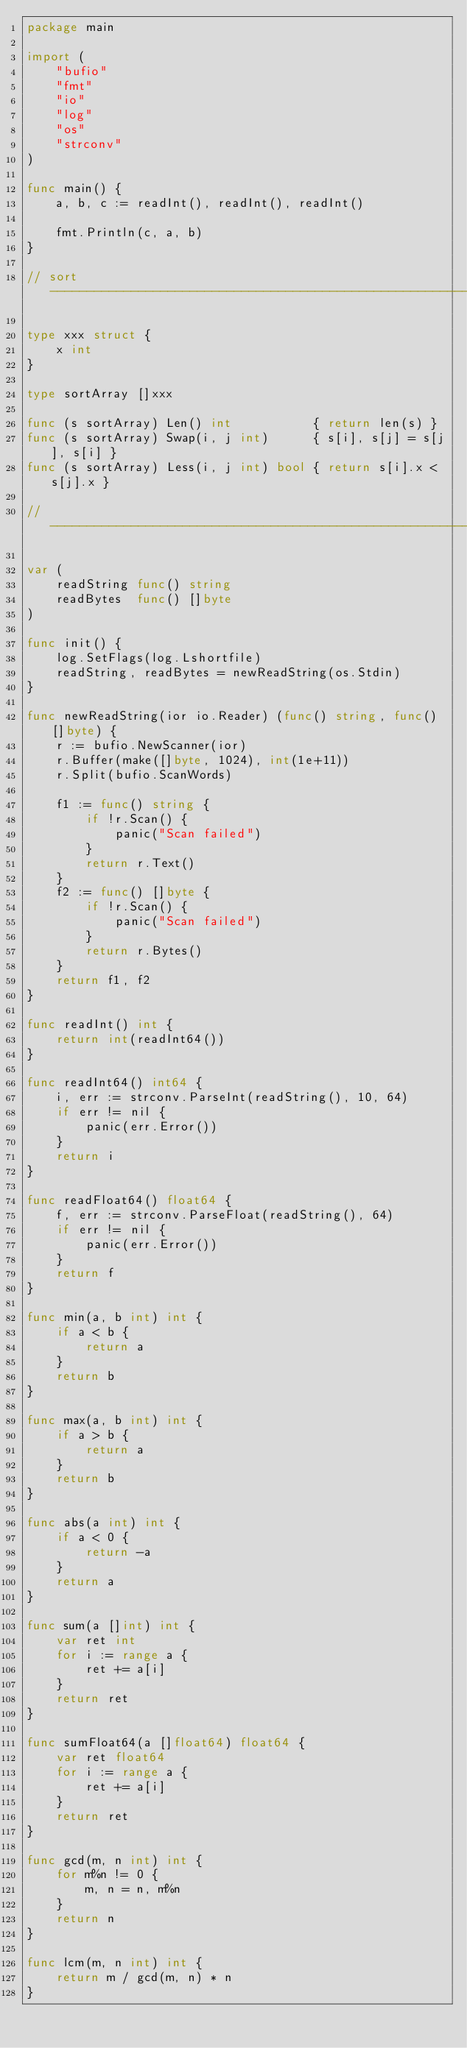Convert code to text. <code><loc_0><loc_0><loc_500><loc_500><_Go_>package main

import (
	"bufio"
	"fmt"
	"io"
	"log"
	"os"
	"strconv"
)

func main() {
	a, b, c := readInt(), readInt(), readInt()

	fmt.Println(c, a, b)
}

// sort ------------------------------------------------------------

type xxx struct {
	x int
}

type sortArray []xxx

func (s sortArray) Len() int           { return len(s) }
func (s sortArray) Swap(i, j int)      { s[i], s[j] = s[j], s[i] }
func (s sortArray) Less(i, j int) bool { return s[i].x < s[j].x }

// -----------------------------------------------------------------

var (
	readString func() string
	readBytes  func() []byte
)

func init() {
	log.SetFlags(log.Lshortfile)
	readString, readBytes = newReadString(os.Stdin)
}

func newReadString(ior io.Reader) (func() string, func() []byte) {
	r := bufio.NewScanner(ior)
	r.Buffer(make([]byte, 1024), int(1e+11))
	r.Split(bufio.ScanWords)

	f1 := func() string {
		if !r.Scan() {
			panic("Scan failed")
		}
		return r.Text()
	}
	f2 := func() []byte {
		if !r.Scan() {
			panic("Scan failed")
		}
		return r.Bytes()
	}
	return f1, f2
}

func readInt() int {
	return int(readInt64())
}

func readInt64() int64 {
	i, err := strconv.ParseInt(readString(), 10, 64)
	if err != nil {
		panic(err.Error())
	}
	return i
}

func readFloat64() float64 {
	f, err := strconv.ParseFloat(readString(), 64)
	if err != nil {
		panic(err.Error())
	}
	return f
}

func min(a, b int) int {
	if a < b {
		return a
	}
	return b
}

func max(a, b int) int {
	if a > b {
		return a
	}
	return b
}

func abs(a int) int {
	if a < 0 {
		return -a
	}
	return a
}

func sum(a []int) int {
	var ret int
	for i := range a {
		ret += a[i]
	}
	return ret
}

func sumFloat64(a []float64) float64 {
	var ret float64
	for i := range a {
		ret += a[i]
	}
	return ret
}

func gcd(m, n int) int {
	for m%n != 0 {
		m, n = n, m%n
	}
	return n
}

func lcm(m, n int) int {
	return m / gcd(m, n) * n
}
</code> 